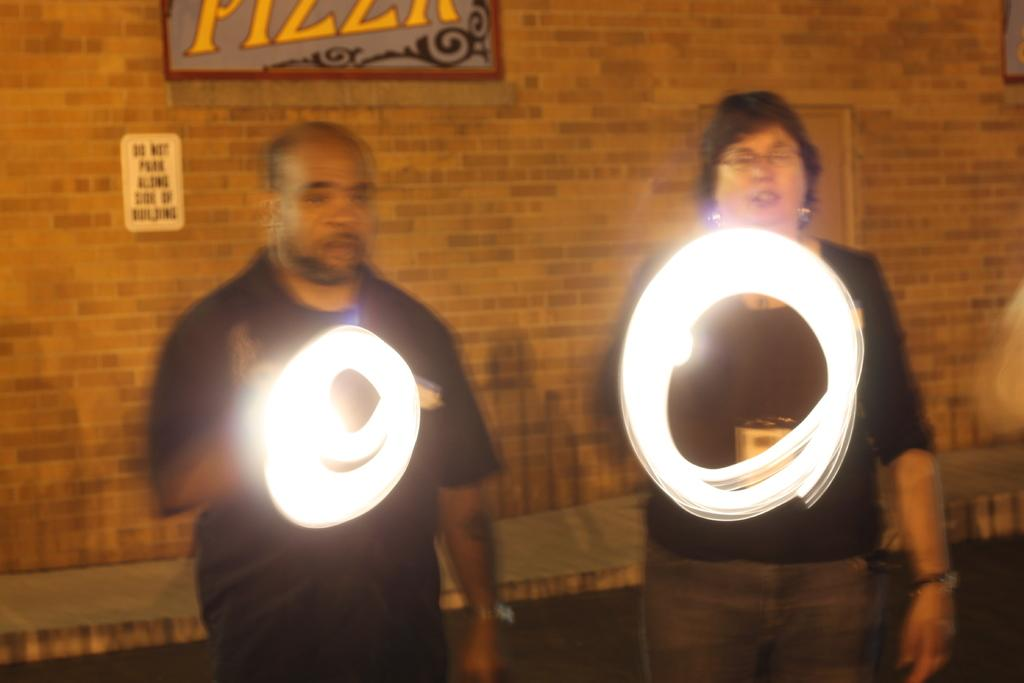How many people are in the image? There are persons in the image, but the exact number is not specified. What is behind the persons in the image? The persons are in front of a wall. What are the persons wearing? The persons are wearing clothes. What are the persons holding in their hands? The persons are holding lights in their hands. What is at the top of the image? There is a board at the top of the image. What type of tree can be seen growing on the wall in the image? There is no tree growing on the wall in the image. 